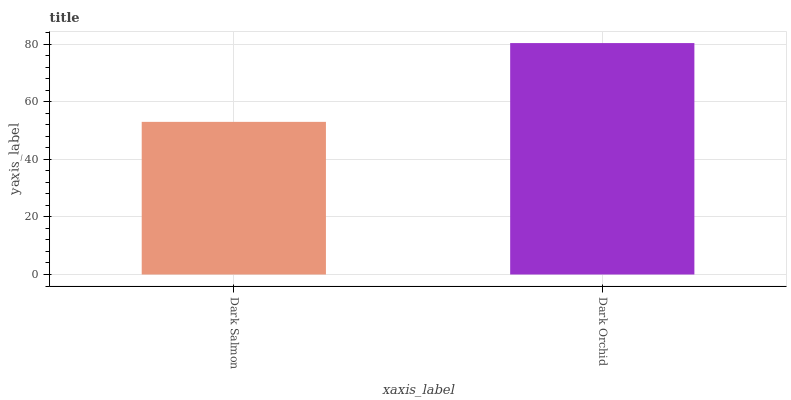Is Dark Salmon the minimum?
Answer yes or no. Yes. Is Dark Orchid the maximum?
Answer yes or no. Yes. Is Dark Orchid the minimum?
Answer yes or no. No. Is Dark Orchid greater than Dark Salmon?
Answer yes or no. Yes. Is Dark Salmon less than Dark Orchid?
Answer yes or no. Yes. Is Dark Salmon greater than Dark Orchid?
Answer yes or no. No. Is Dark Orchid less than Dark Salmon?
Answer yes or no. No. Is Dark Orchid the high median?
Answer yes or no. Yes. Is Dark Salmon the low median?
Answer yes or no. Yes. Is Dark Salmon the high median?
Answer yes or no. No. Is Dark Orchid the low median?
Answer yes or no. No. 